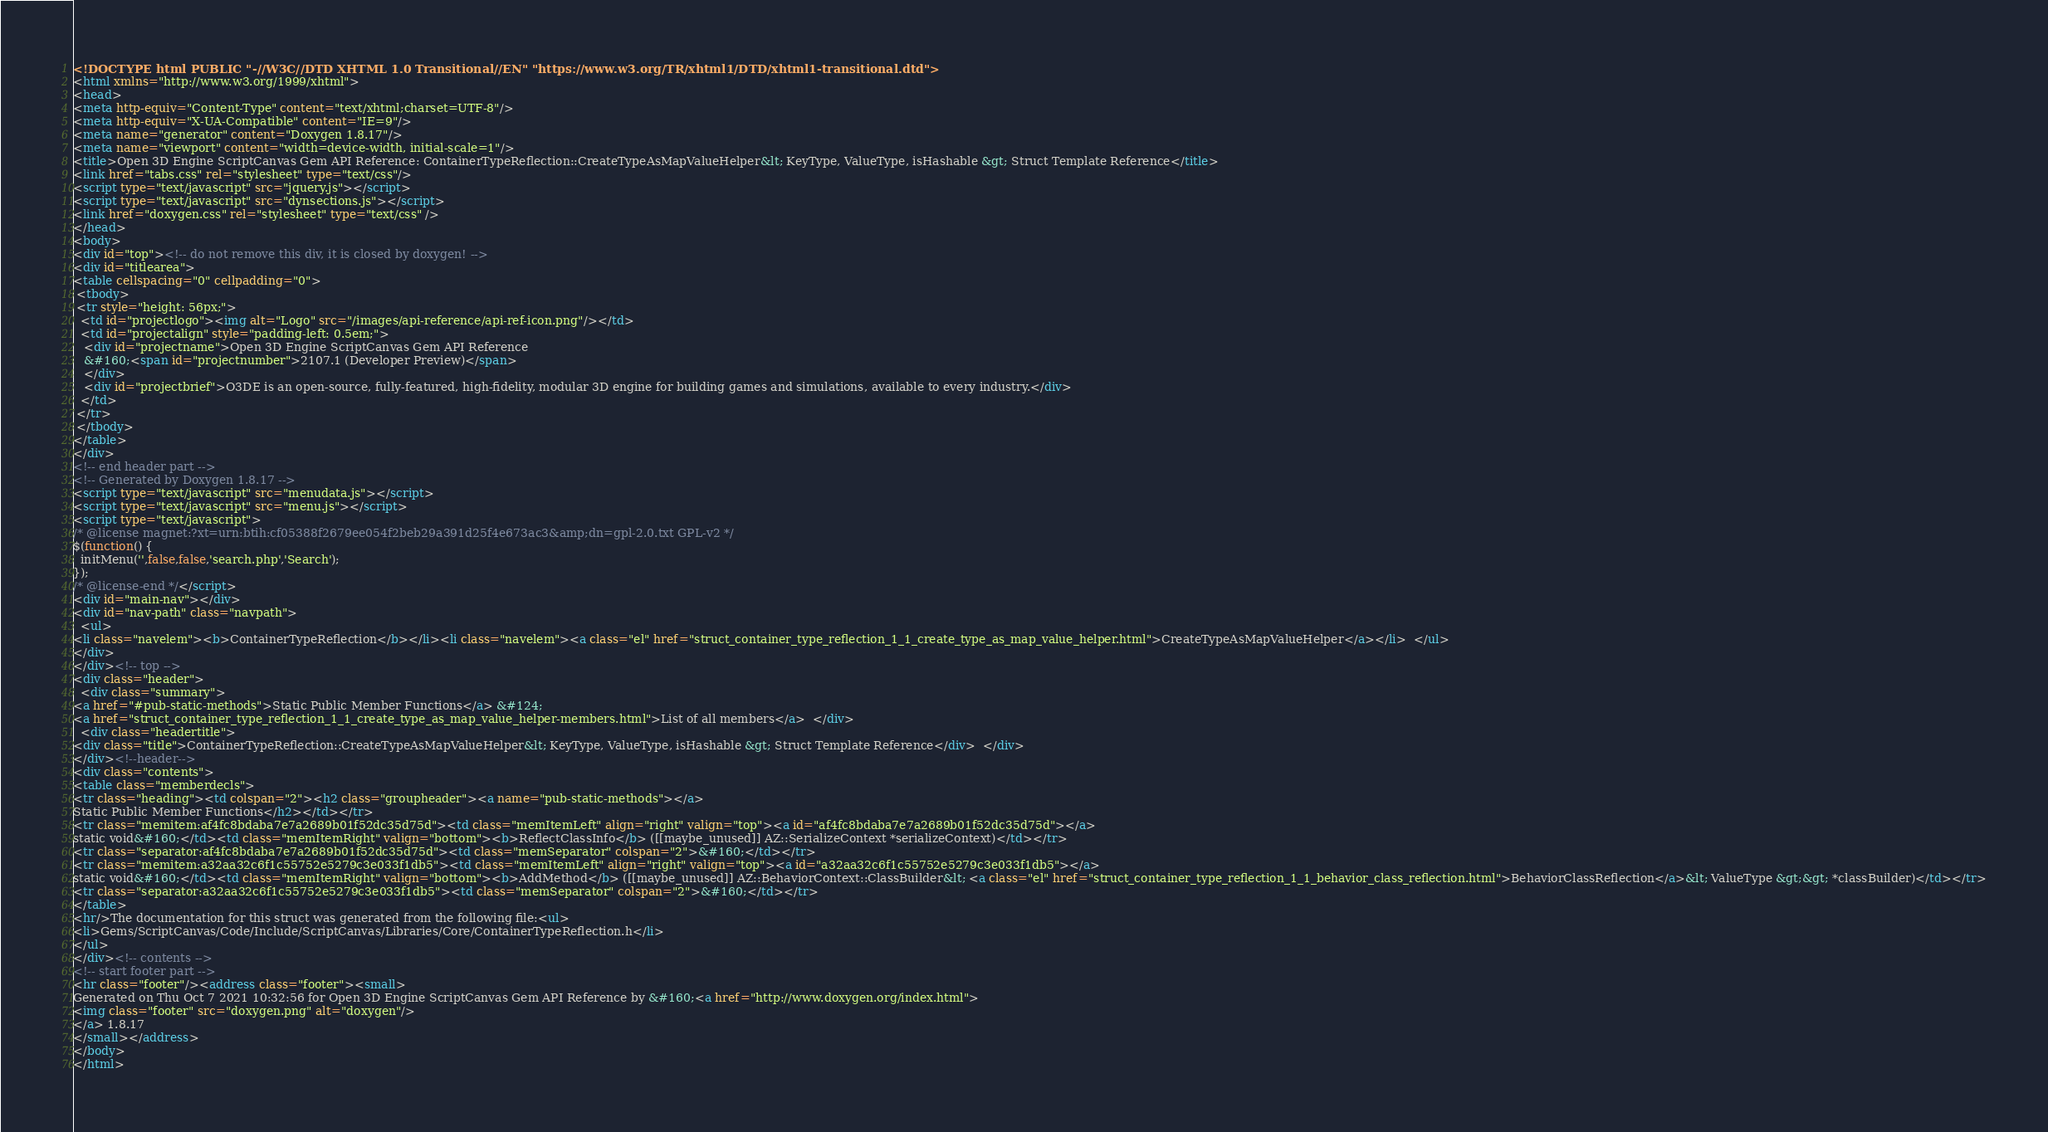Convert code to text. <code><loc_0><loc_0><loc_500><loc_500><_HTML_><!DOCTYPE html PUBLIC "-//W3C//DTD XHTML 1.0 Transitional//EN" "https://www.w3.org/TR/xhtml1/DTD/xhtml1-transitional.dtd">
<html xmlns="http://www.w3.org/1999/xhtml">
<head>
<meta http-equiv="Content-Type" content="text/xhtml;charset=UTF-8"/>
<meta http-equiv="X-UA-Compatible" content="IE=9"/>
<meta name="generator" content="Doxygen 1.8.17"/>
<meta name="viewport" content="width=device-width, initial-scale=1"/>
<title>Open 3D Engine ScriptCanvas Gem API Reference: ContainerTypeReflection::CreateTypeAsMapValueHelper&lt; KeyType, ValueType, isHashable &gt; Struct Template Reference</title>
<link href="tabs.css" rel="stylesheet" type="text/css"/>
<script type="text/javascript" src="jquery.js"></script>
<script type="text/javascript" src="dynsections.js"></script>
<link href="doxygen.css" rel="stylesheet" type="text/css" />
</head>
<body>
<div id="top"><!-- do not remove this div, it is closed by doxygen! -->
<div id="titlearea">
<table cellspacing="0" cellpadding="0">
 <tbody>
 <tr style="height: 56px;">
  <td id="projectlogo"><img alt="Logo" src="/images/api-reference/api-ref-icon.png"/></td>
  <td id="projectalign" style="padding-left: 0.5em;">
   <div id="projectname">Open 3D Engine ScriptCanvas Gem API Reference
   &#160;<span id="projectnumber">2107.1 (Developer Preview)</span>
   </div>
   <div id="projectbrief">O3DE is an open-source, fully-featured, high-fidelity, modular 3D engine for building games and simulations, available to every industry.</div>
  </td>
 </tr>
 </tbody>
</table>
</div>
<!-- end header part -->
<!-- Generated by Doxygen 1.8.17 -->
<script type="text/javascript" src="menudata.js"></script>
<script type="text/javascript" src="menu.js"></script>
<script type="text/javascript">
/* @license magnet:?xt=urn:btih:cf05388f2679ee054f2beb29a391d25f4e673ac3&amp;dn=gpl-2.0.txt GPL-v2 */
$(function() {
  initMenu('',false,false,'search.php','Search');
});
/* @license-end */</script>
<div id="main-nav"></div>
<div id="nav-path" class="navpath">
  <ul>
<li class="navelem"><b>ContainerTypeReflection</b></li><li class="navelem"><a class="el" href="struct_container_type_reflection_1_1_create_type_as_map_value_helper.html">CreateTypeAsMapValueHelper</a></li>  </ul>
</div>
</div><!-- top -->
<div class="header">
  <div class="summary">
<a href="#pub-static-methods">Static Public Member Functions</a> &#124;
<a href="struct_container_type_reflection_1_1_create_type_as_map_value_helper-members.html">List of all members</a>  </div>
  <div class="headertitle">
<div class="title">ContainerTypeReflection::CreateTypeAsMapValueHelper&lt; KeyType, ValueType, isHashable &gt; Struct Template Reference</div>  </div>
</div><!--header-->
<div class="contents">
<table class="memberdecls">
<tr class="heading"><td colspan="2"><h2 class="groupheader"><a name="pub-static-methods"></a>
Static Public Member Functions</h2></td></tr>
<tr class="memitem:af4fc8bdaba7e7a2689b01f52dc35d75d"><td class="memItemLeft" align="right" valign="top"><a id="af4fc8bdaba7e7a2689b01f52dc35d75d"></a>
static void&#160;</td><td class="memItemRight" valign="bottom"><b>ReflectClassInfo</b> ([[maybe_unused]] AZ::SerializeContext *serializeContext)</td></tr>
<tr class="separator:af4fc8bdaba7e7a2689b01f52dc35d75d"><td class="memSeparator" colspan="2">&#160;</td></tr>
<tr class="memitem:a32aa32c6f1c55752e5279c3e033f1db5"><td class="memItemLeft" align="right" valign="top"><a id="a32aa32c6f1c55752e5279c3e033f1db5"></a>
static void&#160;</td><td class="memItemRight" valign="bottom"><b>AddMethod</b> ([[maybe_unused]] AZ::BehaviorContext::ClassBuilder&lt; <a class="el" href="struct_container_type_reflection_1_1_behavior_class_reflection.html">BehaviorClassReflection</a>&lt; ValueType &gt;&gt; *classBuilder)</td></tr>
<tr class="separator:a32aa32c6f1c55752e5279c3e033f1db5"><td class="memSeparator" colspan="2">&#160;</td></tr>
</table>
<hr/>The documentation for this struct was generated from the following file:<ul>
<li>Gems/ScriptCanvas/Code/Include/ScriptCanvas/Libraries/Core/ContainerTypeReflection.h</li>
</ul>
</div><!-- contents -->
<!-- start footer part -->
<hr class="footer"/><address class="footer"><small>
Generated on Thu Oct 7 2021 10:32:56 for Open 3D Engine ScriptCanvas Gem API Reference by &#160;<a href="http://www.doxygen.org/index.html">
<img class="footer" src="doxygen.png" alt="doxygen"/>
</a> 1.8.17
</small></address>
</body>
</html>
</code> 